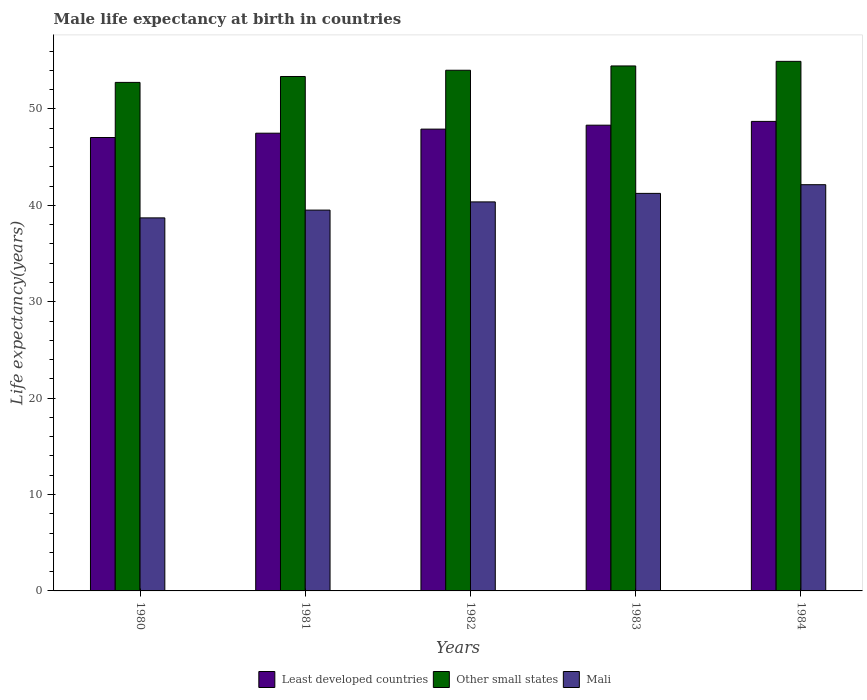How many different coloured bars are there?
Keep it short and to the point. 3. Are the number of bars per tick equal to the number of legend labels?
Your answer should be compact. Yes. Are the number of bars on each tick of the X-axis equal?
Offer a terse response. Yes. What is the male life expectancy at birth in Mali in 1980?
Your answer should be compact. 38.7. Across all years, what is the maximum male life expectancy at birth in Least developed countries?
Ensure brevity in your answer.  48.71. Across all years, what is the minimum male life expectancy at birth in Other small states?
Ensure brevity in your answer.  52.75. In which year was the male life expectancy at birth in Least developed countries maximum?
Make the answer very short. 1984. In which year was the male life expectancy at birth in Least developed countries minimum?
Provide a short and direct response. 1980. What is the total male life expectancy at birth in Least developed countries in the graph?
Offer a very short reply. 239.45. What is the difference between the male life expectancy at birth in Other small states in 1982 and that in 1983?
Provide a short and direct response. -0.44. What is the difference between the male life expectancy at birth in Mali in 1983 and the male life expectancy at birth in Least developed countries in 1980?
Keep it short and to the point. -5.8. What is the average male life expectancy at birth in Other small states per year?
Your answer should be very brief. 53.91. In the year 1984, what is the difference between the male life expectancy at birth in Least developed countries and male life expectancy at birth in Mali?
Give a very brief answer. 6.57. What is the ratio of the male life expectancy at birth in Least developed countries in 1983 to that in 1984?
Provide a succinct answer. 0.99. Is the difference between the male life expectancy at birth in Least developed countries in 1983 and 1984 greater than the difference between the male life expectancy at birth in Mali in 1983 and 1984?
Make the answer very short. Yes. What is the difference between the highest and the second highest male life expectancy at birth in Least developed countries?
Your response must be concise. 0.39. What is the difference between the highest and the lowest male life expectancy at birth in Other small states?
Give a very brief answer. 2.18. In how many years, is the male life expectancy at birth in Least developed countries greater than the average male life expectancy at birth in Least developed countries taken over all years?
Your response must be concise. 3. Is the sum of the male life expectancy at birth in Least developed countries in 1982 and 1983 greater than the maximum male life expectancy at birth in Mali across all years?
Give a very brief answer. Yes. What does the 2nd bar from the left in 1980 represents?
Offer a very short reply. Other small states. What does the 1st bar from the right in 1980 represents?
Offer a terse response. Mali. Is it the case that in every year, the sum of the male life expectancy at birth in Other small states and male life expectancy at birth in Mali is greater than the male life expectancy at birth in Least developed countries?
Your answer should be compact. Yes. Are all the bars in the graph horizontal?
Ensure brevity in your answer.  No. What is the difference between two consecutive major ticks on the Y-axis?
Keep it short and to the point. 10. Are the values on the major ticks of Y-axis written in scientific E-notation?
Offer a terse response. No. Does the graph contain grids?
Offer a terse response. No. How are the legend labels stacked?
Your response must be concise. Horizontal. What is the title of the graph?
Provide a short and direct response. Male life expectancy at birth in countries. Does "Maldives" appear as one of the legend labels in the graph?
Your answer should be very brief. No. What is the label or title of the Y-axis?
Your answer should be very brief. Life expectancy(years). What is the Life expectancy(years) in Least developed countries in 1980?
Ensure brevity in your answer.  47.04. What is the Life expectancy(years) of Other small states in 1980?
Provide a succinct answer. 52.75. What is the Life expectancy(years) of Mali in 1980?
Provide a short and direct response. 38.7. What is the Life expectancy(years) in Least developed countries in 1981?
Offer a terse response. 47.48. What is the Life expectancy(years) of Other small states in 1981?
Your answer should be compact. 53.37. What is the Life expectancy(years) of Mali in 1981?
Your answer should be very brief. 39.51. What is the Life expectancy(years) in Least developed countries in 1982?
Provide a short and direct response. 47.91. What is the Life expectancy(years) of Other small states in 1982?
Give a very brief answer. 54.02. What is the Life expectancy(years) of Mali in 1982?
Your answer should be compact. 40.36. What is the Life expectancy(years) in Least developed countries in 1983?
Make the answer very short. 48.32. What is the Life expectancy(years) of Other small states in 1983?
Your answer should be compact. 54.46. What is the Life expectancy(years) of Mali in 1983?
Your answer should be compact. 41.24. What is the Life expectancy(years) in Least developed countries in 1984?
Provide a succinct answer. 48.71. What is the Life expectancy(years) of Other small states in 1984?
Provide a succinct answer. 54.94. What is the Life expectancy(years) in Mali in 1984?
Keep it short and to the point. 42.14. Across all years, what is the maximum Life expectancy(years) of Least developed countries?
Offer a terse response. 48.71. Across all years, what is the maximum Life expectancy(years) of Other small states?
Provide a short and direct response. 54.94. Across all years, what is the maximum Life expectancy(years) in Mali?
Provide a succinct answer. 42.14. Across all years, what is the minimum Life expectancy(years) of Least developed countries?
Provide a short and direct response. 47.04. Across all years, what is the minimum Life expectancy(years) of Other small states?
Make the answer very short. 52.75. Across all years, what is the minimum Life expectancy(years) of Mali?
Give a very brief answer. 38.7. What is the total Life expectancy(years) in Least developed countries in the graph?
Provide a short and direct response. 239.45. What is the total Life expectancy(years) in Other small states in the graph?
Give a very brief answer. 269.53. What is the total Life expectancy(years) of Mali in the graph?
Provide a short and direct response. 201.95. What is the difference between the Life expectancy(years) in Least developed countries in 1980 and that in 1981?
Your response must be concise. -0.45. What is the difference between the Life expectancy(years) of Other small states in 1980 and that in 1981?
Offer a terse response. -0.61. What is the difference between the Life expectancy(years) of Mali in 1980 and that in 1981?
Give a very brief answer. -0.81. What is the difference between the Life expectancy(years) in Least developed countries in 1980 and that in 1982?
Make the answer very short. -0.87. What is the difference between the Life expectancy(years) of Other small states in 1980 and that in 1982?
Offer a terse response. -1.26. What is the difference between the Life expectancy(years) of Mali in 1980 and that in 1982?
Ensure brevity in your answer.  -1.66. What is the difference between the Life expectancy(years) of Least developed countries in 1980 and that in 1983?
Ensure brevity in your answer.  -1.28. What is the difference between the Life expectancy(years) in Other small states in 1980 and that in 1983?
Give a very brief answer. -1.71. What is the difference between the Life expectancy(years) in Mali in 1980 and that in 1983?
Ensure brevity in your answer.  -2.54. What is the difference between the Life expectancy(years) in Least developed countries in 1980 and that in 1984?
Keep it short and to the point. -1.67. What is the difference between the Life expectancy(years) in Other small states in 1980 and that in 1984?
Your response must be concise. -2.18. What is the difference between the Life expectancy(years) in Mali in 1980 and that in 1984?
Provide a succinct answer. -3.44. What is the difference between the Life expectancy(years) in Least developed countries in 1981 and that in 1982?
Your answer should be compact. -0.42. What is the difference between the Life expectancy(years) of Other small states in 1981 and that in 1982?
Your answer should be very brief. -0.65. What is the difference between the Life expectancy(years) of Mali in 1981 and that in 1982?
Your answer should be compact. -0.85. What is the difference between the Life expectancy(years) of Least developed countries in 1981 and that in 1983?
Your response must be concise. -0.83. What is the difference between the Life expectancy(years) of Other small states in 1981 and that in 1983?
Make the answer very short. -1.09. What is the difference between the Life expectancy(years) in Mali in 1981 and that in 1983?
Provide a succinct answer. -1.73. What is the difference between the Life expectancy(years) of Least developed countries in 1981 and that in 1984?
Your answer should be very brief. -1.22. What is the difference between the Life expectancy(years) of Other small states in 1981 and that in 1984?
Keep it short and to the point. -1.57. What is the difference between the Life expectancy(years) in Mali in 1981 and that in 1984?
Make the answer very short. -2.63. What is the difference between the Life expectancy(years) in Least developed countries in 1982 and that in 1983?
Your answer should be compact. -0.41. What is the difference between the Life expectancy(years) in Other small states in 1982 and that in 1983?
Your response must be concise. -0.44. What is the difference between the Life expectancy(years) in Mali in 1982 and that in 1983?
Offer a very short reply. -0.88. What is the difference between the Life expectancy(years) in Least developed countries in 1982 and that in 1984?
Your response must be concise. -0.8. What is the difference between the Life expectancy(years) in Other small states in 1982 and that in 1984?
Your answer should be compact. -0.92. What is the difference between the Life expectancy(years) of Mali in 1982 and that in 1984?
Your response must be concise. -1.78. What is the difference between the Life expectancy(years) in Least developed countries in 1983 and that in 1984?
Provide a succinct answer. -0.39. What is the difference between the Life expectancy(years) in Other small states in 1983 and that in 1984?
Offer a terse response. -0.48. What is the difference between the Life expectancy(years) in Mali in 1983 and that in 1984?
Provide a succinct answer. -0.9. What is the difference between the Life expectancy(years) in Least developed countries in 1980 and the Life expectancy(years) in Other small states in 1981?
Provide a short and direct response. -6.33. What is the difference between the Life expectancy(years) of Least developed countries in 1980 and the Life expectancy(years) of Mali in 1981?
Offer a very short reply. 7.53. What is the difference between the Life expectancy(years) in Other small states in 1980 and the Life expectancy(years) in Mali in 1981?
Give a very brief answer. 13.25. What is the difference between the Life expectancy(years) in Least developed countries in 1980 and the Life expectancy(years) in Other small states in 1982?
Ensure brevity in your answer.  -6.98. What is the difference between the Life expectancy(years) of Least developed countries in 1980 and the Life expectancy(years) of Mali in 1982?
Keep it short and to the point. 6.68. What is the difference between the Life expectancy(years) of Other small states in 1980 and the Life expectancy(years) of Mali in 1982?
Offer a very short reply. 12.4. What is the difference between the Life expectancy(years) in Least developed countries in 1980 and the Life expectancy(years) in Other small states in 1983?
Make the answer very short. -7.42. What is the difference between the Life expectancy(years) of Least developed countries in 1980 and the Life expectancy(years) of Mali in 1983?
Offer a terse response. 5.8. What is the difference between the Life expectancy(years) of Other small states in 1980 and the Life expectancy(years) of Mali in 1983?
Give a very brief answer. 11.51. What is the difference between the Life expectancy(years) in Least developed countries in 1980 and the Life expectancy(years) in Other small states in 1984?
Offer a terse response. -7.9. What is the difference between the Life expectancy(years) of Least developed countries in 1980 and the Life expectancy(years) of Mali in 1984?
Make the answer very short. 4.89. What is the difference between the Life expectancy(years) in Other small states in 1980 and the Life expectancy(years) in Mali in 1984?
Your response must be concise. 10.61. What is the difference between the Life expectancy(years) in Least developed countries in 1981 and the Life expectancy(years) in Other small states in 1982?
Offer a very short reply. -6.53. What is the difference between the Life expectancy(years) in Least developed countries in 1981 and the Life expectancy(years) in Mali in 1982?
Keep it short and to the point. 7.13. What is the difference between the Life expectancy(years) of Other small states in 1981 and the Life expectancy(years) of Mali in 1982?
Keep it short and to the point. 13.01. What is the difference between the Life expectancy(years) of Least developed countries in 1981 and the Life expectancy(years) of Other small states in 1983?
Your response must be concise. -6.98. What is the difference between the Life expectancy(years) of Least developed countries in 1981 and the Life expectancy(years) of Mali in 1983?
Offer a very short reply. 6.24. What is the difference between the Life expectancy(years) in Other small states in 1981 and the Life expectancy(years) in Mali in 1983?
Your response must be concise. 12.13. What is the difference between the Life expectancy(years) of Least developed countries in 1981 and the Life expectancy(years) of Other small states in 1984?
Your answer should be compact. -7.45. What is the difference between the Life expectancy(years) of Least developed countries in 1981 and the Life expectancy(years) of Mali in 1984?
Offer a very short reply. 5.34. What is the difference between the Life expectancy(years) in Other small states in 1981 and the Life expectancy(years) in Mali in 1984?
Ensure brevity in your answer.  11.22. What is the difference between the Life expectancy(years) of Least developed countries in 1982 and the Life expectancy(years) of Other small states in 1983?
Offer a very short reply. -6.55. What is the difference between the Life expectancy(years) in Least developed countries in 1982 and the Life expectancy(years) in Mali in 1983?
Keep it short and to the point. 6.67. What is the difference between the Life expectancy(years) in Other small states in 1982 and the Life expectancy(years) in Mali in 1983?
Your answer should be compact. 12.77. What is the difference between the Life expectancy(years) of Least developed countries in 1982 and the Life expectancy(years) of Other small states in 1984?
Your answer should be compact. -7.03. What is the difference between the Life expectancy(years) of Least developed countries in 1982 and the Life expectancy(years) of Mali in 1984?
Offer a very short reply. 5.77. What is the difference between the Life expectancy(years) of Other small states in 1982 and the Life expectancy(years) of Mali in 1984?
Ensure brevity in your answer.  11.87. What is the difference between the Life expectancy(years) in Least developed countries in 1983 and the Life expectancy(years) in Other small states in 1984?
Your answer should be compact. -6.62. What is the difference between the Life expectancy(years) of Least developed countries in 1983 and the Life expectancy(years) of Mali in 1984?
Provide a succinct answer. 6.17. What is the difference between the Life expectancy(years) of Other small states in 1983 and the Life expectancy(years) of Mali in 1984?
Your answer should be compact. 12.32. What is the average Life expectancy(years) in Least developed countries per year?
Your answer should be very brief. 47.89. What is the average Life expectancy(years) in Other small states per year?
Keep it short and to the point. 53.91. What is the average Life expectancy(years) in Mali per year?
Offer a terse response. 40.39. In the year 1980, what is the difference between the Life expectancy(years) in Least developed countries and Life expectancy(years) in Other small states?
Ensure brevity in your answer.  -5.72. In the year 1980, what is the difference between the Life expectancy(years) of Least developed countries and Life expectancy(years) of Mali?
Offer a very short reply. 8.34. In the year 1980, what is the difference between the Life expectancy(years) of Other small states and Life expectancy(years) of Mali?
Your answer should be compact. 14.05. In the year 1981, what is the difference between the Life expectancy(years) in Least developed countries and Life expectancy(years) in Other small states?
Ensure brevity in your answer.  -5.88. In the year 1981, what is the difference between the Life expectancy(years) of Least developed countries and Life expectancy(years) of Mali?
Ensure brevity in your answer.  7.98. In the year 1981, what is the difference between the Life expectancy(years) in Other small states and Life expectancy(years) in Mali?
Keep it short and to the point. 13.86. In the year 1982, what is the difference between the Life expectancy(years) in Least developed countries and Life expectancy(years) in Other small states?
Offer a terse response. -6.11. In the year 1982, what is the difference between the Life expectancy(years) in Least developed countries and Life expectancy(years) in Mali?
Keep it short and to the point. 7.55. In the year 1982, what is the difference between the Life expectancy(years) in Other small states and Life expectancy(years) in Mali?
Make the answer very short. 13.66. In the year 1983, what is the difference between the Life expectancy(years) of Least developed countries and Life expectancy(years) of Other small states?
Offer a terse response. -6.14. In the year 1983, what is the difference between the Life expectancy(years) of Least developed countries and Life expectancy(years) of Mali?
Give a very brief answer. 7.07. In the year 1983, what is the difference between the Life expectancy(years) in Other small states and Life expectancy(years) in Mali?
Offer a terse response. 13.22. In the year 1984, what is the difference between the Life expectancy(years) in Least developed countries and Life expectancy(years) in Other small states?
Keep it short and to the point. -6.23. In the year 1984, what is the difference between the Life expectancy(years) of Least developed countries and Life expectancy(years) of Mali?
Your response must be concise. 6.57. In the year 1984, what is the difference between the Life expectancy(years) of Other small states and Life expectancy(years) of Mali?
Ensure brevity in your answer.  12.8. What is the ratio of the Life expectancy(years) of Least developed countries in 1980 to that in 1981?
Make the answer very short. 0.99. What is the ratio of the Life expectancy(years) of Mali in 1980 to that in 1981?
Ensure brevity in your answer.  0.98. What is the ratio of the Life expectancy(years) in Least developed countries in 1980 to that in 1982?
Offer a terse response. 0.98. What is the ratio of the Life expectancy(years) of Other small states in 1980 to that in 1982?
Offer a very short reply. 0.98. What is the ratio of the Life expectancy(years) in Mali in 1980 to that in 1982?
Offer a terse response. 0.96. What is the ratio of the Life expectancy(years) in Least developed countries in 1980 to that in 1983?
Keep it short and to the point. 0.97. What is the ratio of the Life expectancy(years) in Other small states in 1980 to that in 1983?
Provide a succinct answer. 0.97. What is the ratio of the Life expectancy(years) in Mali in 1980 to that in 1983?
Your response must be concise. 0.94. What is the ratio of the Life expectancy(years) of Least developed countries in 1980 to that in 1984?
Keep it short and to the point. 0.97. What is the ratio of the Life expectancy(years) of Other small states in 1980 to that in 1984?
Offer a terse response. 0.96. What is the ratio of the Life expectancy(years) in Mali in 1980 to that in 1984?
Your response must be concise. 0.92. What is the ratio of the Life expectancy(years) in Least developed countries in 1981 to that in 1982?
Keep it short and to the point. 0.99. What is the ratio of the Life expectancy(years) in Mali in 1981 to that in 1982?
Offer a terse response. 0.98. What is the ratio of the Life expectancy(years) in Least developed countries in 1981 to that in 1983?
Provide a short and direct response. 0.98. What is the ratio of the Life expectancy(years) of Other small states in 1981 to that in 1983?
Keep it short and to the point. 0.98. What is the ratio of the Life expectancy(years) of Mali in 1981 to that in 1983?
Your response must be concise. 0.96. What is the ratio of the Life expectancy(years) in Least developed countries in 1981 to that in 1984?
Your answer should be compact. 0.97. What is the ratio of the Life expectancy(years) of Other small states in 1981 to that in 1984?
Offer a very short reply. 0.97. What is the ratio of the Life expectancy(years) in Mali in 1981 to that in 1984?
Ensure brevity in your answer.  0.94. What is the ratio of the Life expectancy(years) of Least developed countries in 1982 to that in 1983?
Keep it short and to the point. 0.99. What is the ratio of the Life expectancy(years) in Other small states in 1982 to that in 1983?
Your answer should be very brief. 0.99. What is the ratio of the Life expectancy(years) in Mali in 1982 to that in 1983?
Offer a terse response. 0.98. What is the ratio of the Life expectancy(years) in Least developed countries in 1982 to that in 1984?
Offer a very short reply. 0.98. What is the ratio of the Life expectancy(years) of Other small states in 1982 to that in 1984?
Ensure brevity in your answer.  0.98. What is the ratio of the Life expectancy(years) of Mali in 1982 to that in 1984?
Keep it short and to the point. 0.96. What is the ratio of the Life expectancy(years) in Other small states in 1983 to that in 1984?
Give a very brief answer. 0.99. What is the ratio of the Life expectancy(years) in Mali in 1983 to that in 1984?
Ensure brevity in your answer.  0.98. What is the difference between the highest and the second highest Life expectancy(years) in Least developed countries?
Offer a terse response. 0.39. What is the difference between the highest and the second highest Life expectancy(years) of Other small states?
Offer a very short reply. 0.48. What is the difference between the highest and the second highest Life expectancy(years) of Mali?
Give a very brief answer. 0.9. What is the difference between the highest and the lowest Life expectancy(years) in Least developed countries?
Offer a terse response. 1.67. What is the difference between the highest and the lowest Life expectancy(years) in Other small states?
Keep it short and to the point. 2.18. What is the difference between the highest and the lowest Life expectancy(years) in Mali?
Give a very brief answer. 3.44. 